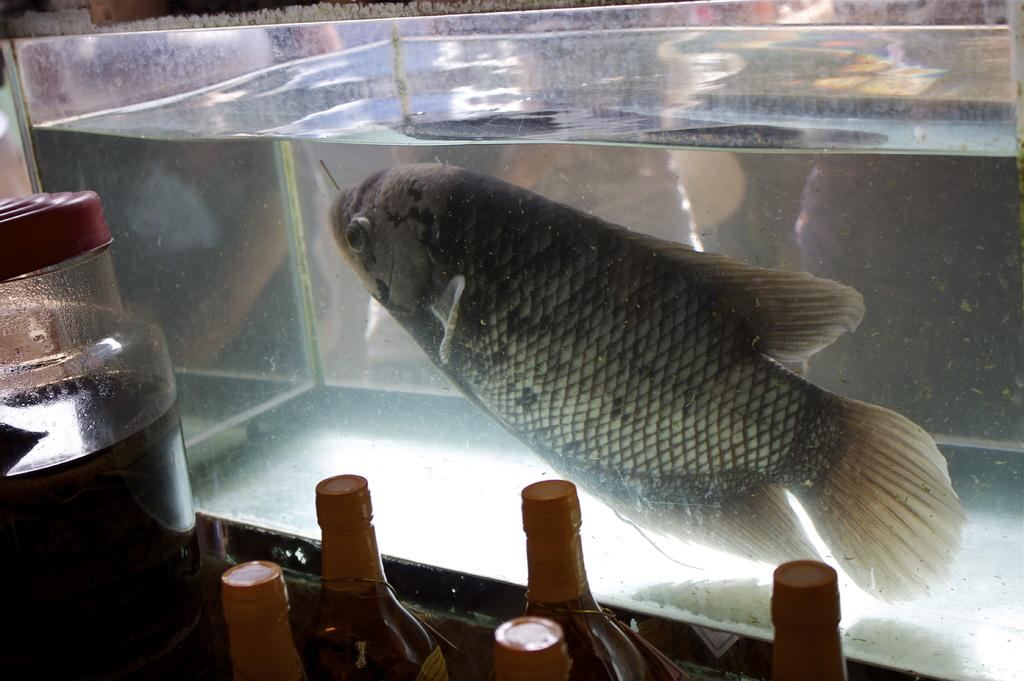What type of containers can be seen in the image? There are bottles and a jar in the image. What is inside the jar? The contents of the jar are not visible in the image. What can be found in the aquarium? There is a fish and water in the aquarium. What is the main feature of the aquarium? The main feature of the aquarium is the fish. What type of religion is practiced by the fish in the image? There is no indication of religion in the image, as it features bottles, a jar, and an aquarium with a fish and water. 